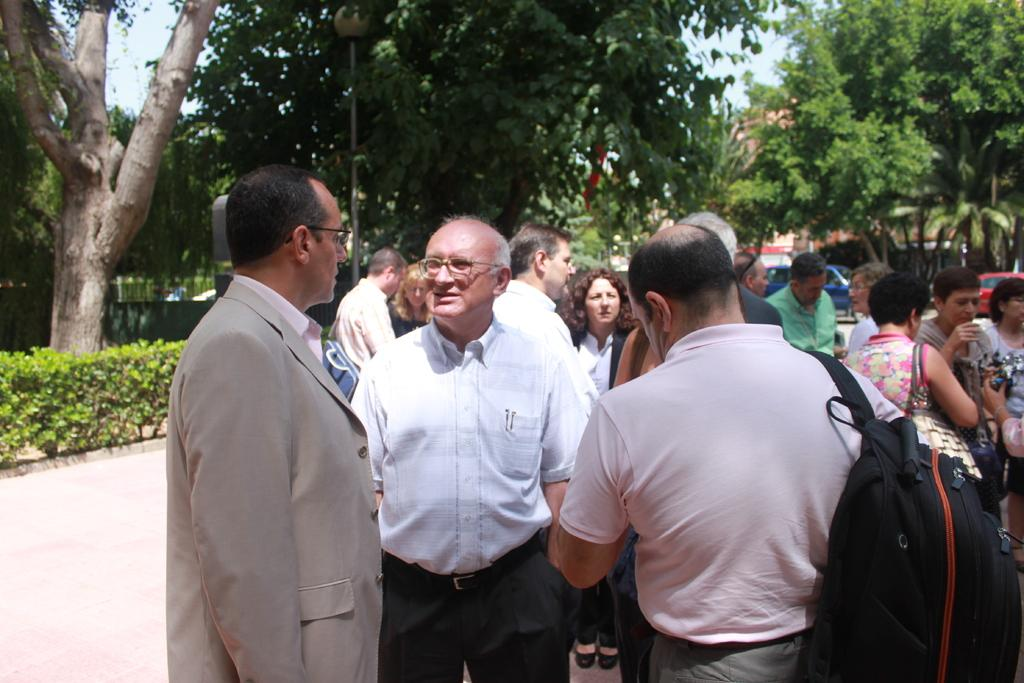Who or what can be seen in the image? There are people in the image. What are some of the people carrying on their backs? Some of the people are wearing backpacks. What type of natural environment is visible in the image? There are trees and plants in the image. What type of mine can be seen in the image? There is no mine present in the image. What kind of field is visible in the image? There is no field visible in the image. 